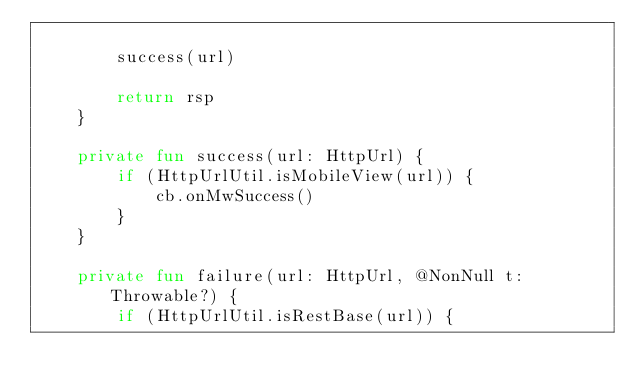<code> <loc_0><loc_0><loc_500><loc_500><_Kotlin_>
        success(url)

        return rsp
    }

    private fun success(url: HttpUrl) {
        if (HttpUrlUtil.isMobileView(url)) {
            cb.onMwSuccess()
        }
    }

    private fun failure(url: HttpUrl, @NonNull t: Throwable?) {
        if (HttpUrlUtil.isRestBase(url)) {</code> 